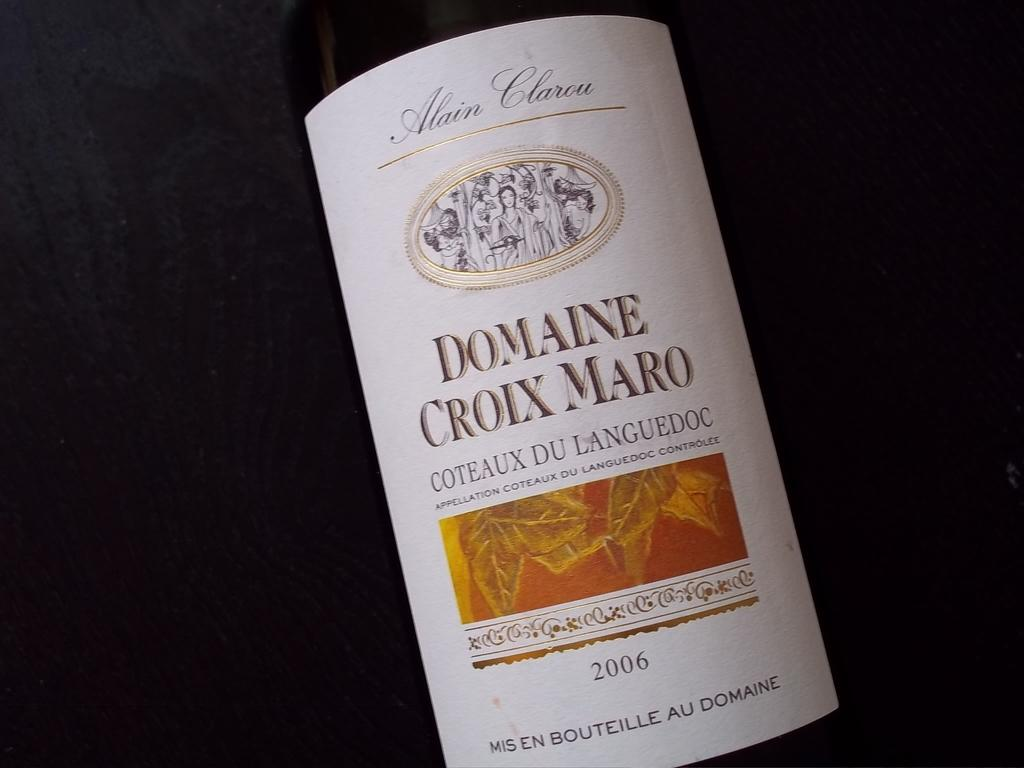Provide a one-sentence caption for the provided image. A bottle of wine bottle label shows a date of 2006. 